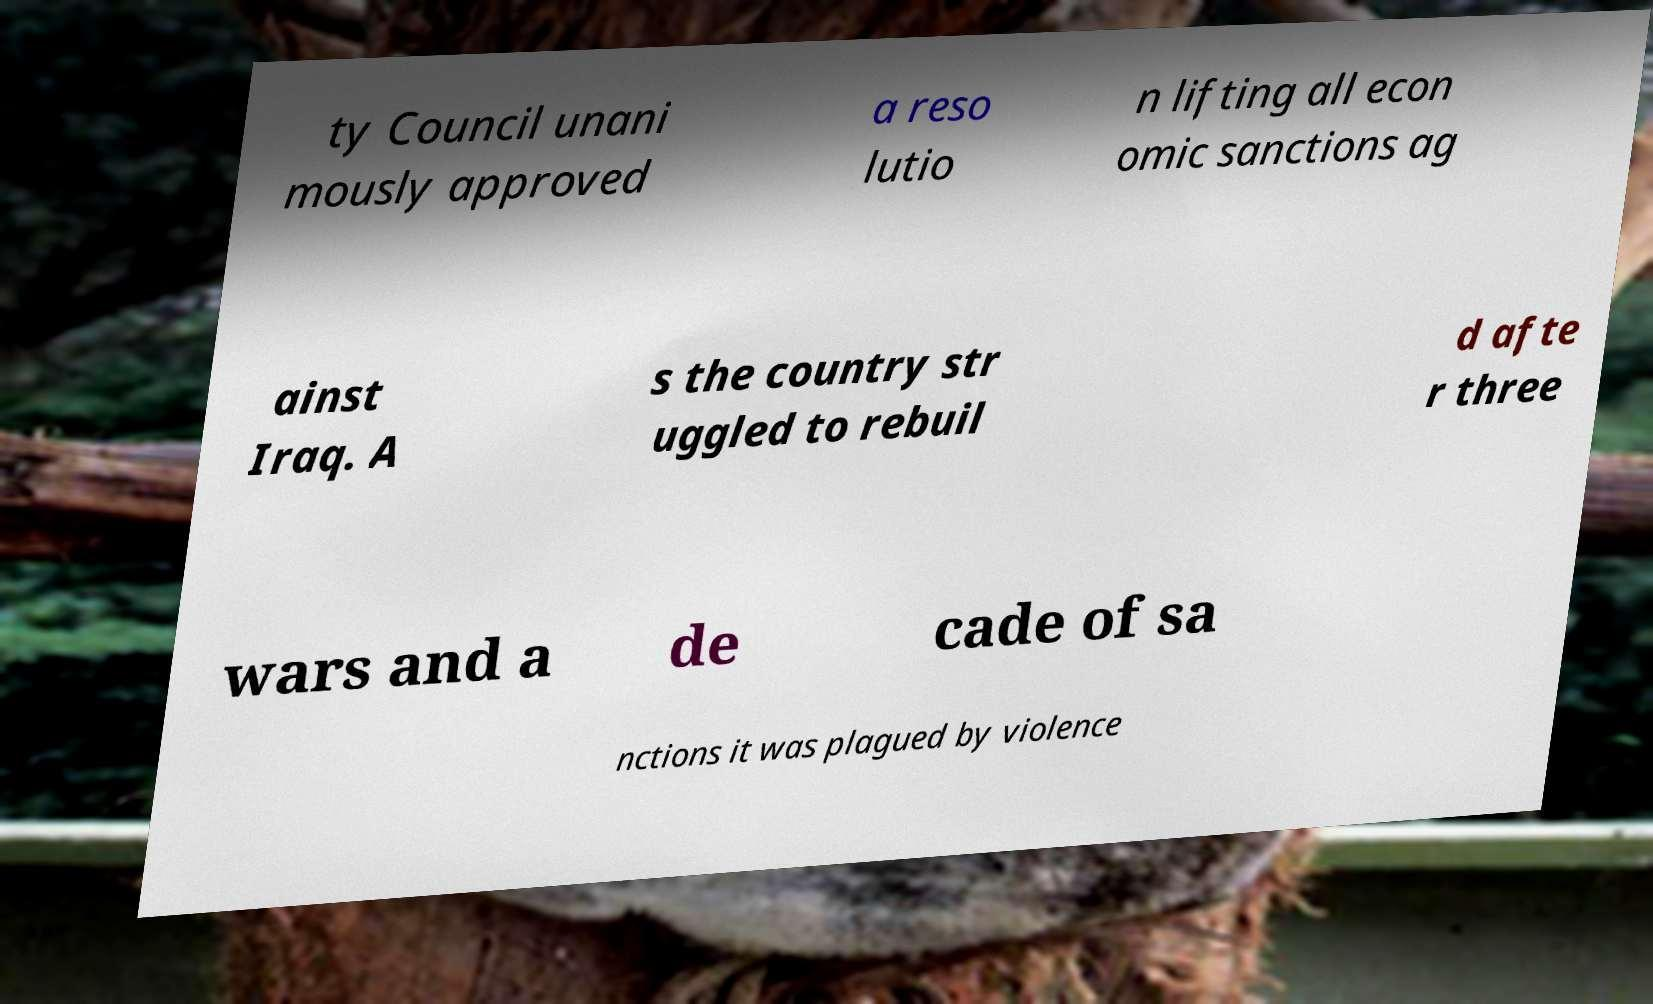Could you extract and type out the text from this image? ty Council unani mously approved a reso lutio n lifting all econ omic sanctions ag ainst Iraq. A s the country str uggled to rebuil d afte r three wars and a de cade of sa nctions it was plagued by violence 